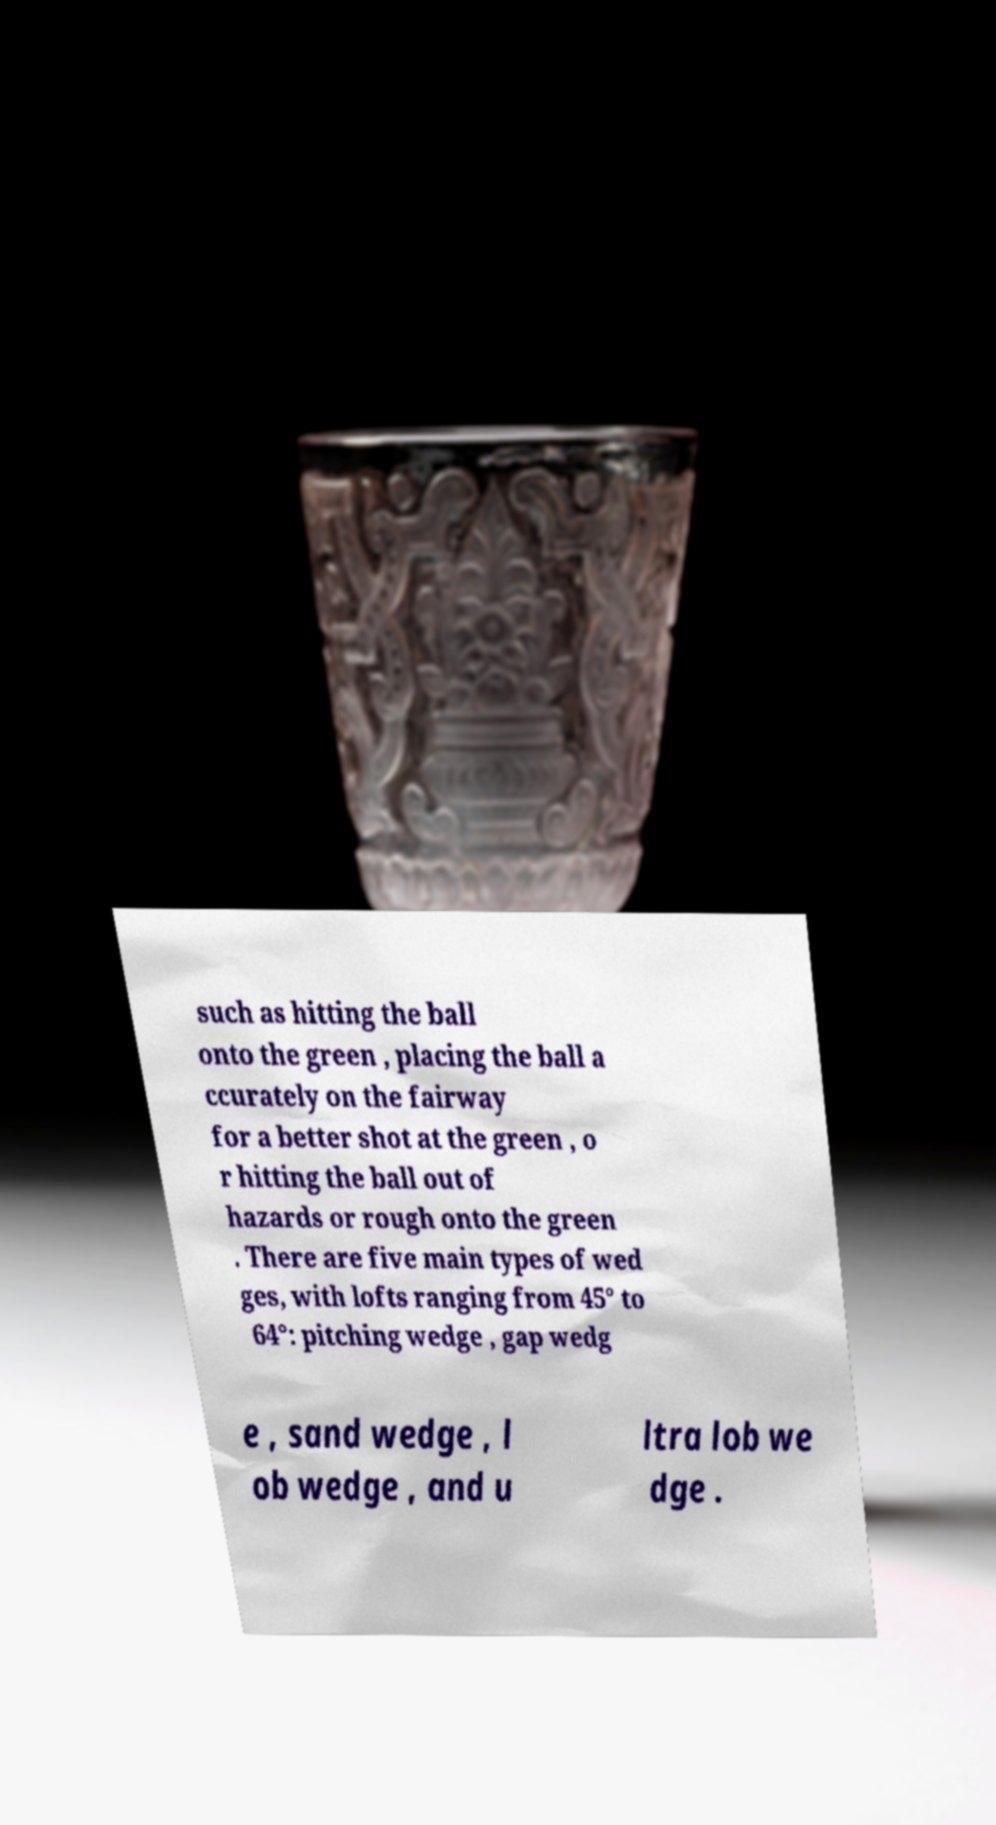Could you assist in decoding the text presented in this image and type it out clearly? such as hitting the ball onto the green , placing the ball a ccurately on the fairway for a better shot at the green , o r hitting the ball out of hazards or rough onto the green . There are five main types of wed ges, with lofts ranging from 45° to 64°: pitching wedge , gap wedg e , sand wedge , l ob wedge , and u ltra lob we dge . 